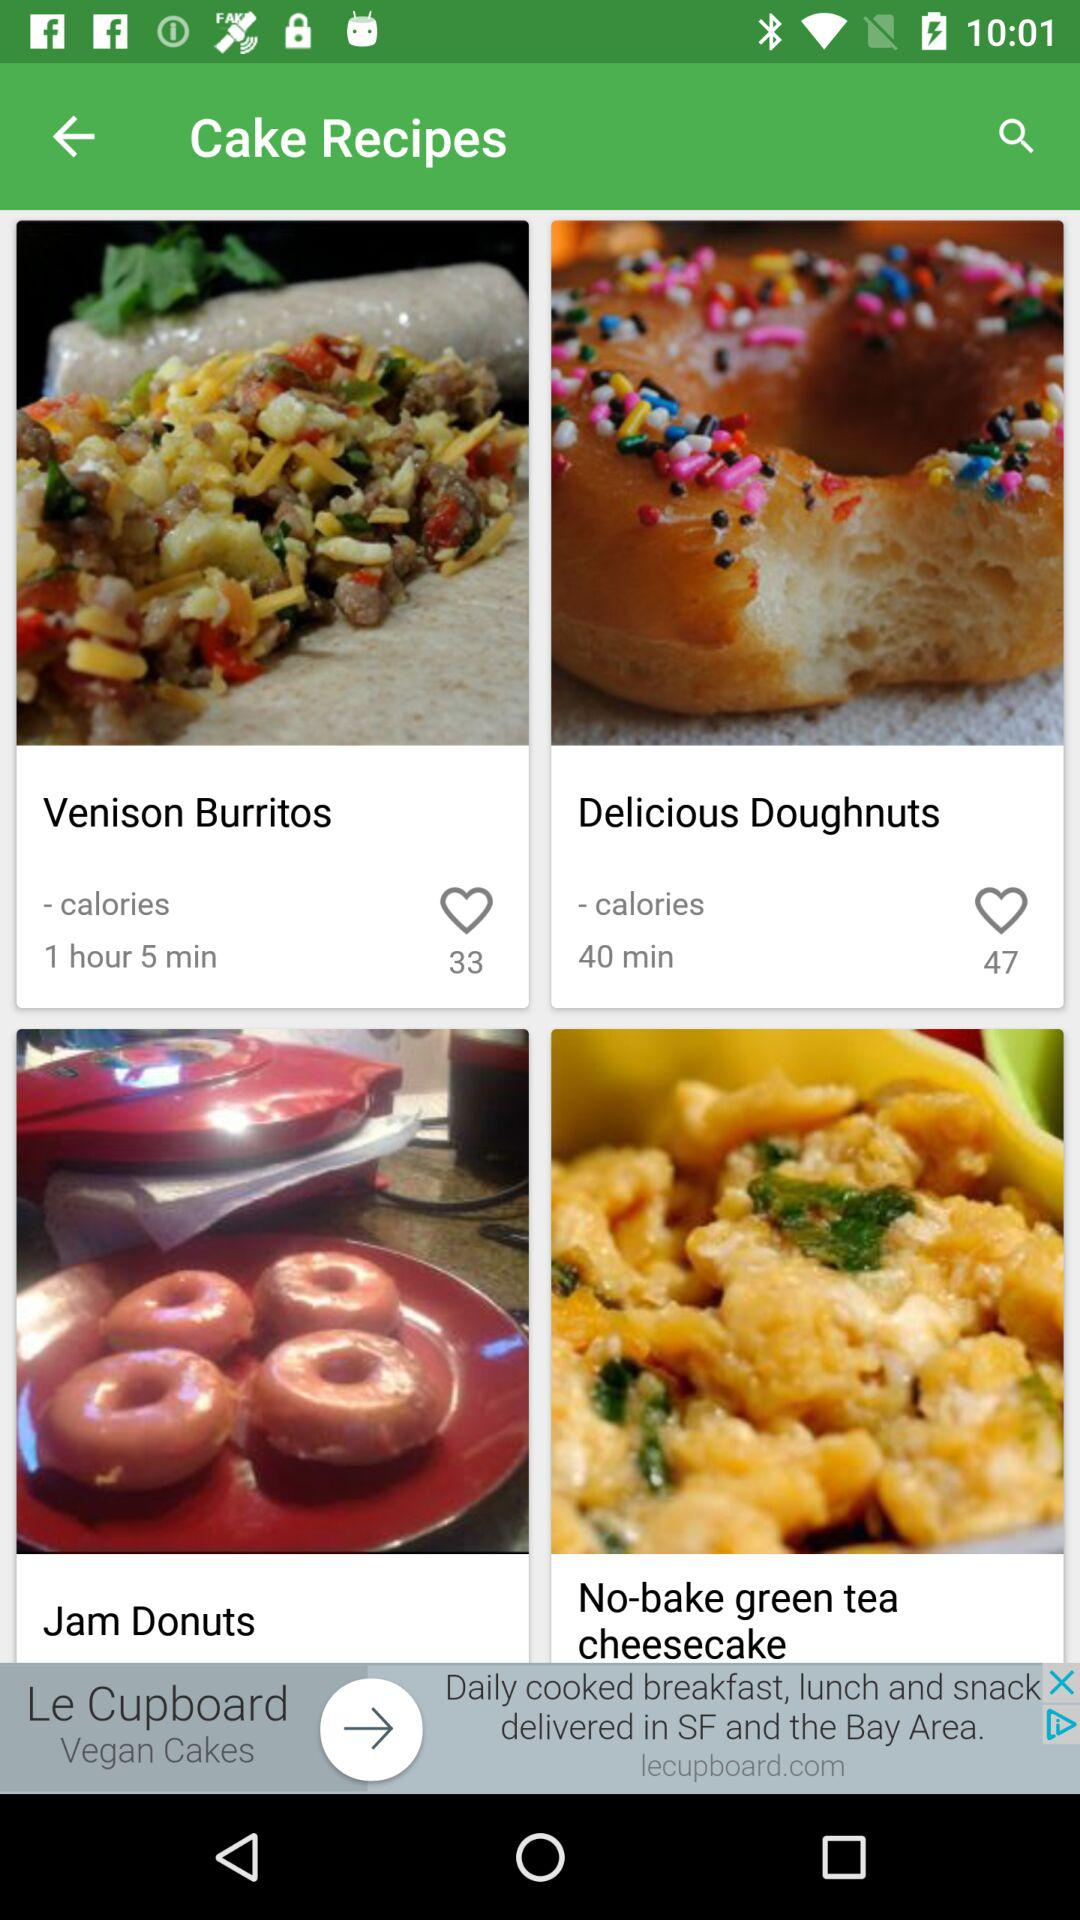What are the available dish names? The available dish names are "Venison Burritos", "Delicious Doughnuts", "Jam Donuts" and "No-bake green tea cheesecake". 